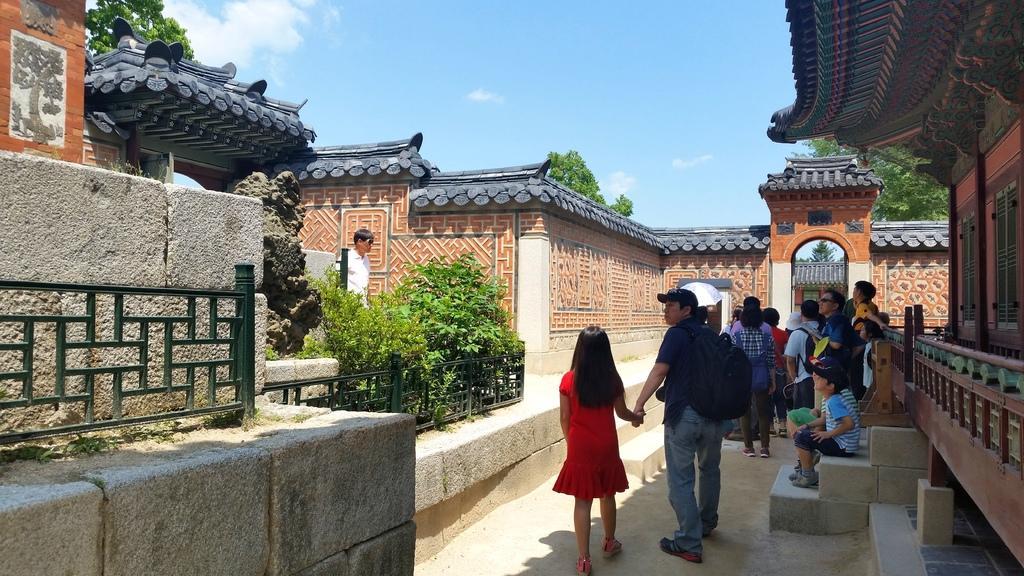Could you give a brief overview of what you see in this image? There are many people. Some are wearing caps. On the right side there is a building with steps. On the left side there are railings, plants and a building with brick wall. In the background there are trees and sky with clouds. Also there is an arch in the background. 